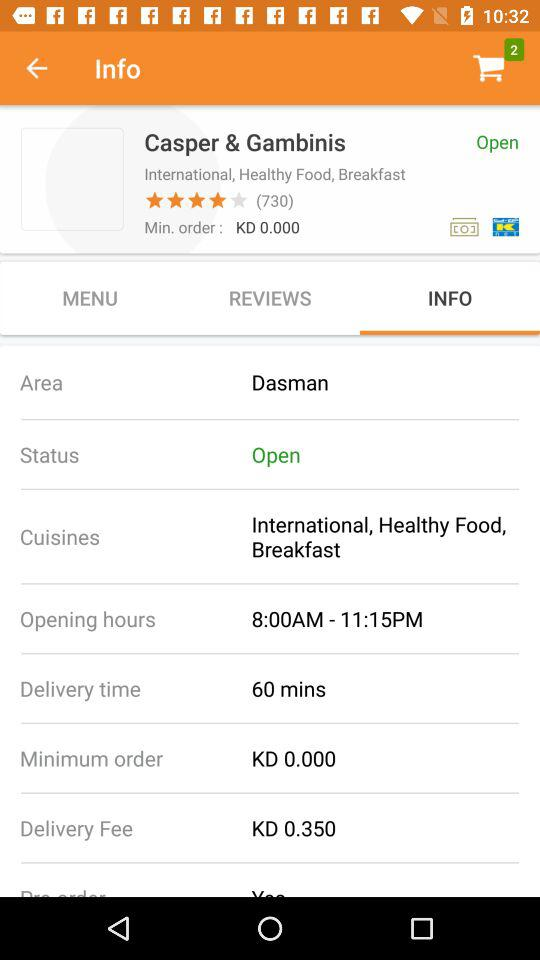How much is the delivery fee?
Answer the question using a single word or phrase. KD 0.350 